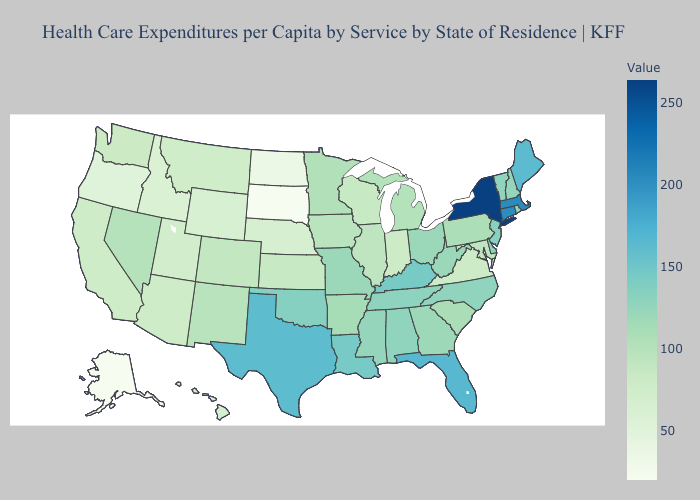Does Louisiana have the lowest value in the South?
Be succinct. No. Does Nevada have the highest value in the West?
Give a very brief answer. Yes. Does New York have the highest value in the USA?
Give a very brief answer. Yes. Does New Mexico have the highest value in the West?
Answer briefly. No. Among the states that border California , which have the lowest value?
Write a very short answer. Oregon. 